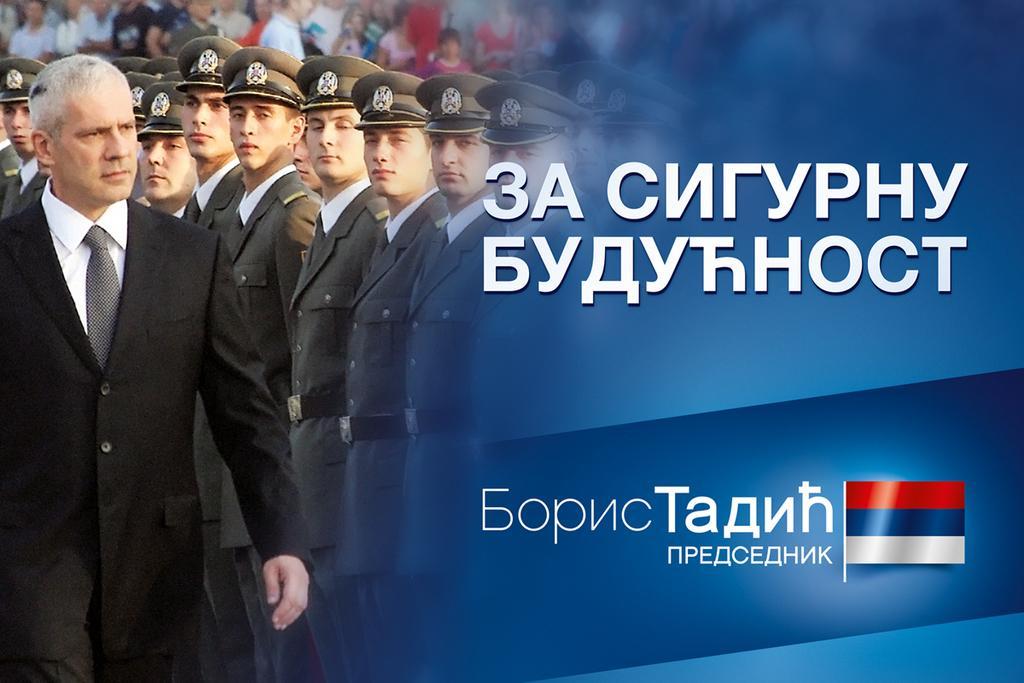How would you summarize this image in a sentence or two? In this picture on the right side, we can see a flag on a blue screen and on the left side, we can see many people standing and looking somewhere. 